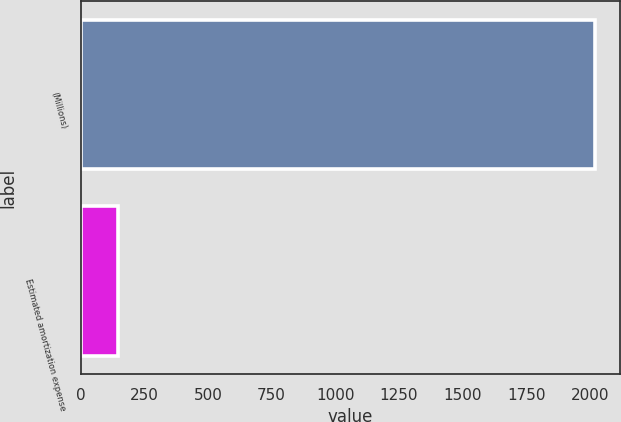Convert chart to OTSL. <chart><loc_0><loc_0><loc_500><loc_500><bar_chart><fcel>(Millions)<fcel>Estimated amortization expense<nl><fcel>2019<fcel>146<nl></chart> 